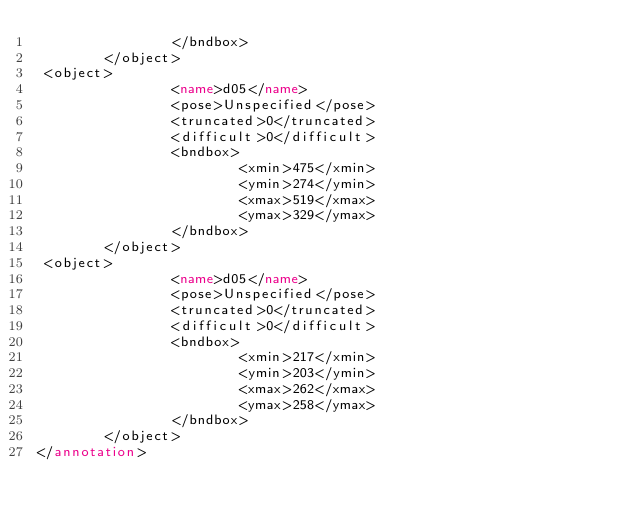<code> <loc_0><loc_0><loc_500><loc_500><_XML_>                </bndbox>
        </object>
 <object>
                <name>d05</name>
                <pose>Unspecified</pose>
                <truncated>0</truncated>
                <difficult>0</difficult>
                <bndbox>
                        <xmin>475</xmin>
                        <ymin>274</ymin>
                        <xmax>519</xmax>
                        <ymax>329</ymax>
                </bndbox>
        </object>
 <object>
                <name>d05</name>
                <pose>Unspecified</pose>
                <truncated>0</truncated>
                <difficult>0</difficult>
                <bndbox>
                        <xmin>217</xmin>
                        <ymin>203</ymin>
                        <xmax>262</xmax>
                        <ymax>258</ymax>
                </bndbox>
        </object>
</annotation>
</code> 